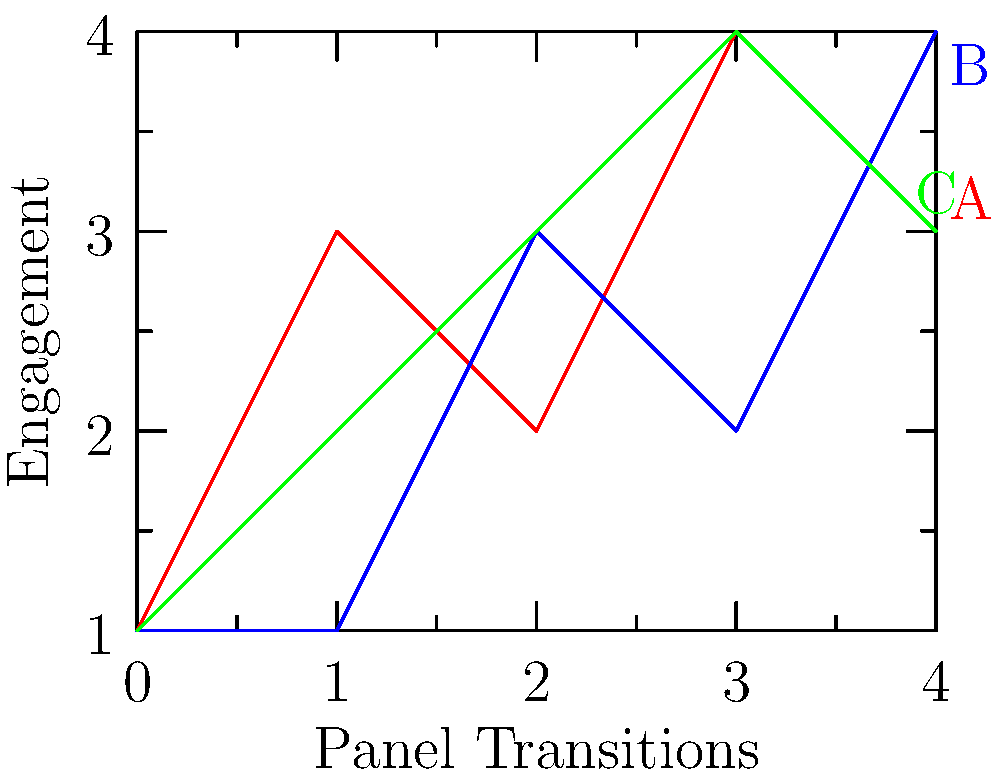As an art director evaluating panel transitions in sequential art, which transition style (A, B, or C) would you recommend for a high-impact action sequence in a graphic novel, based on the engagement patterns shown in the graph? To determine the most effective transition style for a high-impact action sequence, we need to analyze the engagement patterns of each style:

1. Style A (red line):
   - Shows rapid fluctuations in engagement
   - Peaks at panel 2 and 4
   - Indicates dynamic, possibly jarring transitions

2. Style B (blue line):
   - Starts low and steadily increases
   - Highest engagement at the final panel
   - Suggests a gradual build-up of tension

3. Style C (green line):
   - Shows a consistent increase in engagement until panel 4
   - Slight decrease at the final panel
   - Indicates a steady escalation with a resolution

For a high-impact action sequence, we want to maintain high engagement throughout with moments of intensity. Style A provides this with its rapid fluctuations, creating a sense of urgency and excitement. The peaks at panels 2 and 4 can represent climactic moments in the action.

Style B, while ending strongly, may not capture the immediate intensity required for an action sequence. Style C provides a good build-up but lacks the dynamic shifts that can enhance the feeling of action.

Therefore, Style A would be the most effective for a high-impact action sequence, as it maintains high engagement with dynamic shifts that mirror the excitement of action scenes.
Answer: Style A 